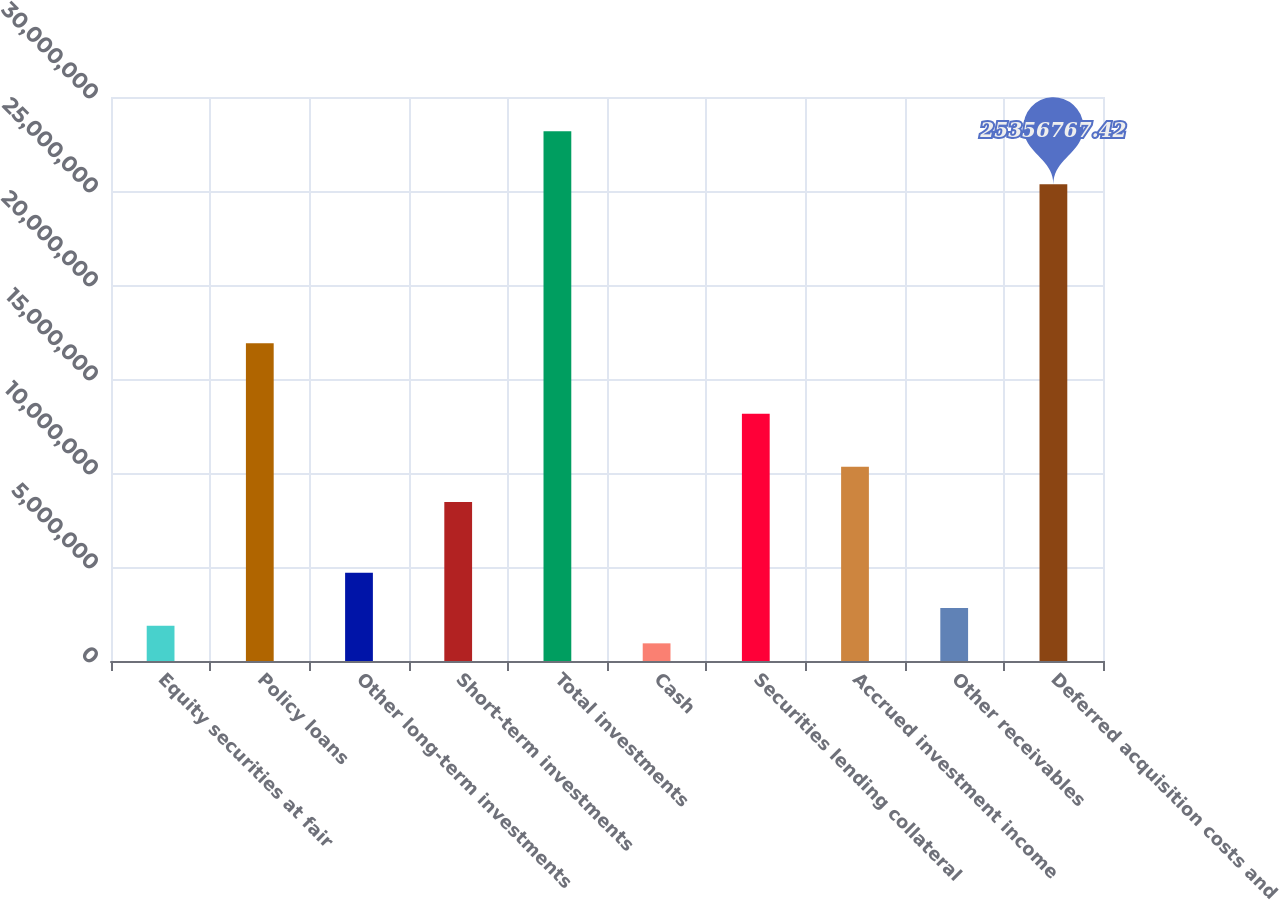Convert chart. <chart><loc_0><loc_0><loc_500><loc_500><bar_chart><fcel>Equity securities at fair<fcel>Policy loans<fcel>Other long-term investments<fcel>Short-term investments<fcel>Total investments<fcel>Cash<fcel>Securities lending collateral<fcel>Accrued investment income<fcel>Other receivables<fcel>Deferred acquisition costs and<nl><fcel>1.87828e+06<fcel>1.69045e+07<fcel>4.6957e+06<fcel>8.45226e+06<fcel>2.81742e+07<fcel>939144<fcel>1.3148e+07<fcel>1.03305e+07<fcel>2.81742e+06<fcel>2.53568e+07<nl></chart> 